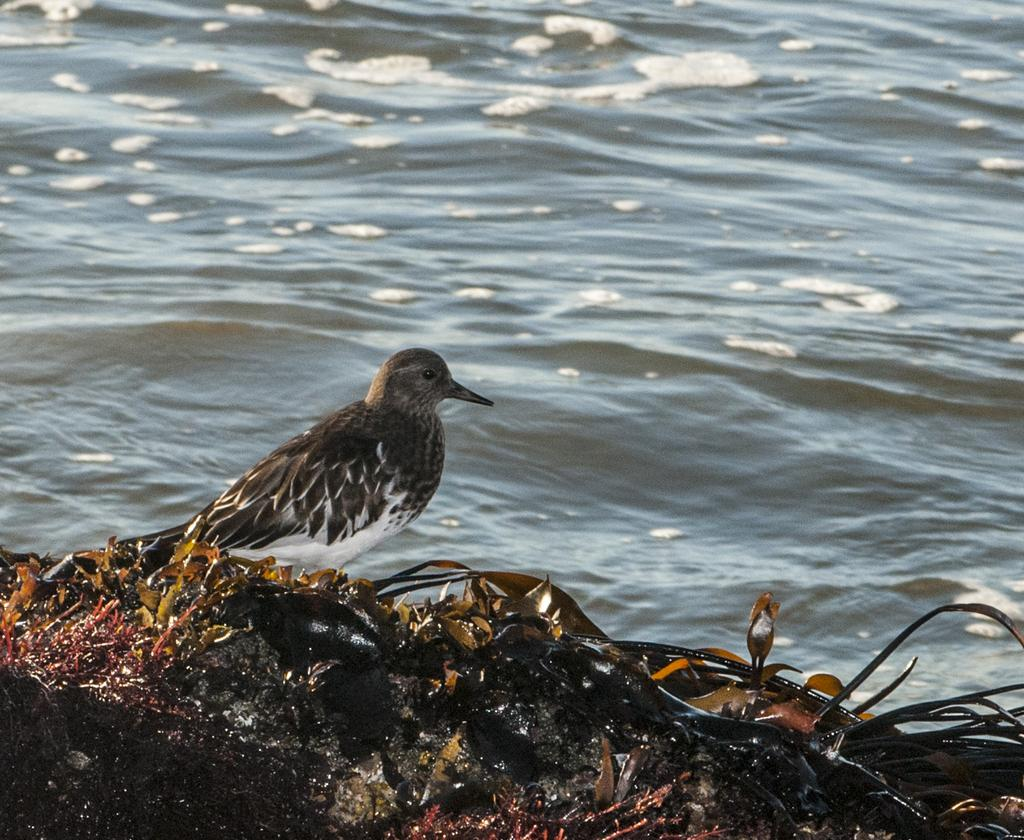What type of animal is in the image? There is a bird in the image. What is the bird standing on? The bird is standing on leaves. What can be seen in the background of the image? There is a water surface visible in the image. What type of holiday is the bird celebrating in the image? There is no indication of a holiday in the image; it simply shows a bird standing on leaves with a water surface in the background. 